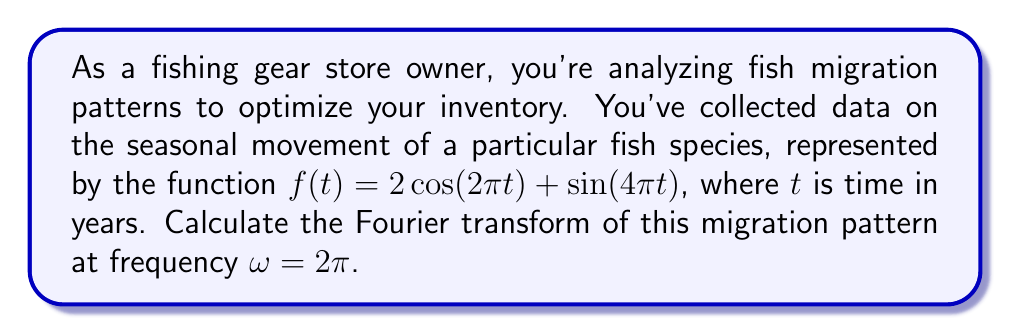Could you help me with this problem? To solve this problem, we'll follow these steps:

1) The Fourier transform of a function $f(t)$ is defined as:

   $$F(\omega) = \int_{-\infty}^{\infty} f(t) e^{-i\omega t} dt$$

2) Our function is $f(t) = 2\cos(2\pi t) + \sin(4\pi t)$. We need to calculate $F(2\pi)$.

3) Let's break this into two parts:
   
   $F_1(2\pi)$ for $2\cos(2\pi t)$ and $F_2(2\pi)$ for $\sin(4\pi t)$

4) For $F_1(2\pi)$:
   
   $$F_1(2\pi) = 2\int_{-\infty}^{\infty} \cos(2\pi t) e^{-i2\pi t} dt$$

   Using Euler's formula, $\cos(2\pi t) = \frac{e^{i2\pi t} + e^{-i2\pi t}}{2}$

   $$F_1(2\pi) = \int_{-\infty}^{\infty} (e^{i2\pi t} + e^{-i2\pi t}) e^{-i2\pi t} dt$$
   
   $$= \int_{-\infty}^{\infty} (1 + e^{-i4\pi t}) dt$$

   The integral of 1 over infinite limits is a delta function: $2\pi\delta(0)$
   The integral of $e^{-i4\pi t}$ is zero.

   So, $F_1(2\pi) = 2\pi\delta(0)$

5) For $F_2(2\pi)$:
   
   $$F_2(2\pi) = \int_{-\infty}^{\infty} \sin(4\pi t) e^{-i2\pi t} dt$$

   Using $\sin(4\pi t) = \frac{e^{i4\pi t} - e^{-i4\pi t}}{2i}$

   $$F_2(2\pi) = \frac{1}{2i}\int_{-\infty}^{\infty} (e^{i4\pi t} - e^{-i4\pi t}) e^{-i2\pi t} dt$$
   
   $$= \frac{1}{2i}\int_{-\infty}^{\infty} (e^{i2\pi t} - e^{-i6\pi t}) dt$$

   Both integrals are zero as they are complex exponentials with non-zero frequencies.

   So, $F_2(2\pi) = 0$

6) The total Fourier transform is the sum of $F_1(2\pi)$ and $F_2(2\pi)$:

   $F(2\pi) = F_1(2\pi) + F_2(2\pi) = 2\pi\delta(0) + 0 = 2\pi\delta(0)$
Answer: $2\pi\delta(0)$ 